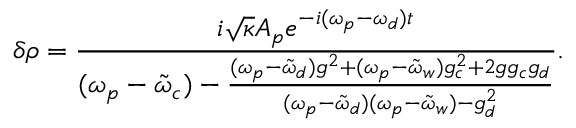Convert formula to latex. <formula><loc_0><loc_0><loc_500><loc_500>\delta \rho = \frac { i \sqrt { \kappa } A _ { p } e ^ { - i ( \omega _ { p } - \omega _ { d } ) t } } { ( \omega _ { p } - \tilde { \omega } _ { c } ) - \frac { ( \omega _ { p } - \tilde { \omega } _ { d } ) g ^ { 2 } + ( \omega _ { p } - \tilde { \omega } _ { w } ) g _ { c } ^ { 2 } + 2 g g _ { c } g _ { d } } { ( \omega _ { p } - \tilde { \omega } _ { d } ) ( \omega _ { p } - \tilde { \omega } _ { w } ) - g _ { d } ^ { 2 } } } .</formula> 